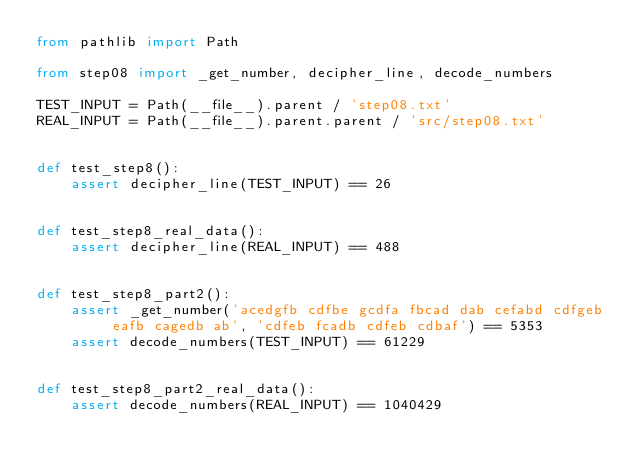Convert code to text. <code><loc_0><loc_0><loc_500><loc_500><_Python_>from pathlib import Path

from step08 import _get_number, decipher_line, decode_numbers

TEST_INPUT = Path(__file__).parent / 'step08.txt'
REAL_INPUT = Path(__file__).parent.parent / 'src/step08.txt'


def test_step8():
    assert decipher_line(TEST_INPUT) == 26


def test_step8_real_data():
    assert decipher_line(REAL_INPUT) == 488


def test_step8_part2():
    assert _get_number('acedgfb cdfbe gcdfa fbcad dab cefabd cdfgeb eafb cagedb ab', 'cdfeb fcadb cdfeb cdbaf') == 5353
    assert decode_numbers(TEST_INPUT) == 61229


def test_step8_part2_real_data():
    assert decode_numbers(REAL_INPUT) == 1040429
</code> 